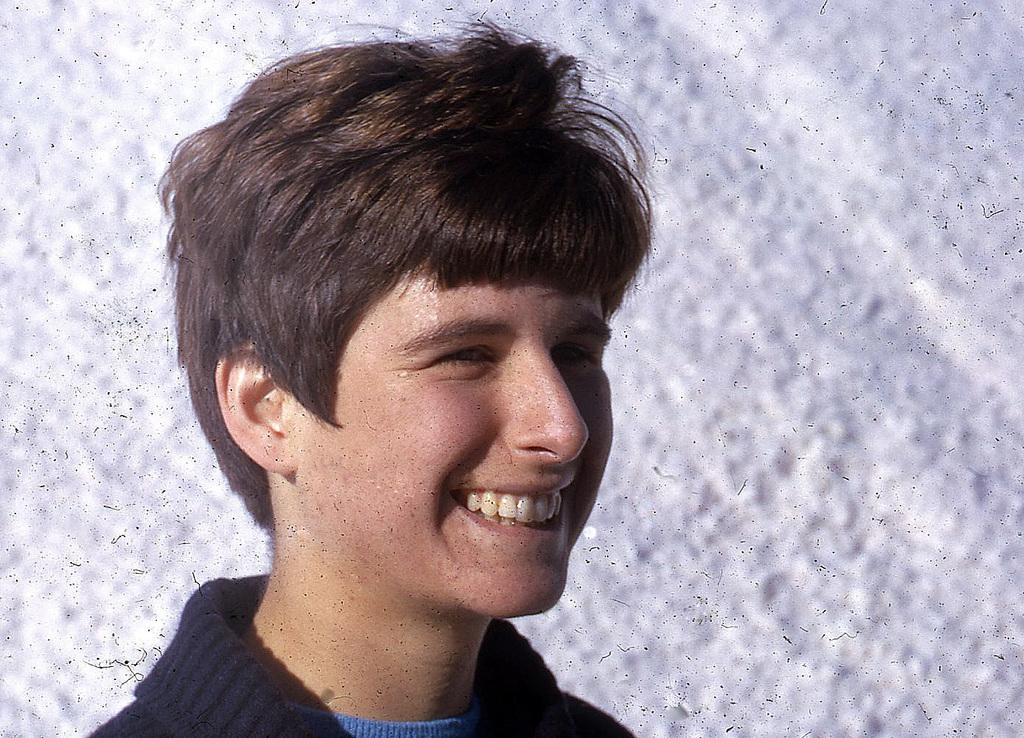Who is present in the image? There is a boy in the image. What is the boy's facial expression? The boy is smiling. How many babies are crawling in the middle of the image? There are no babies present in the image, and the image does not show any crawling activity. 